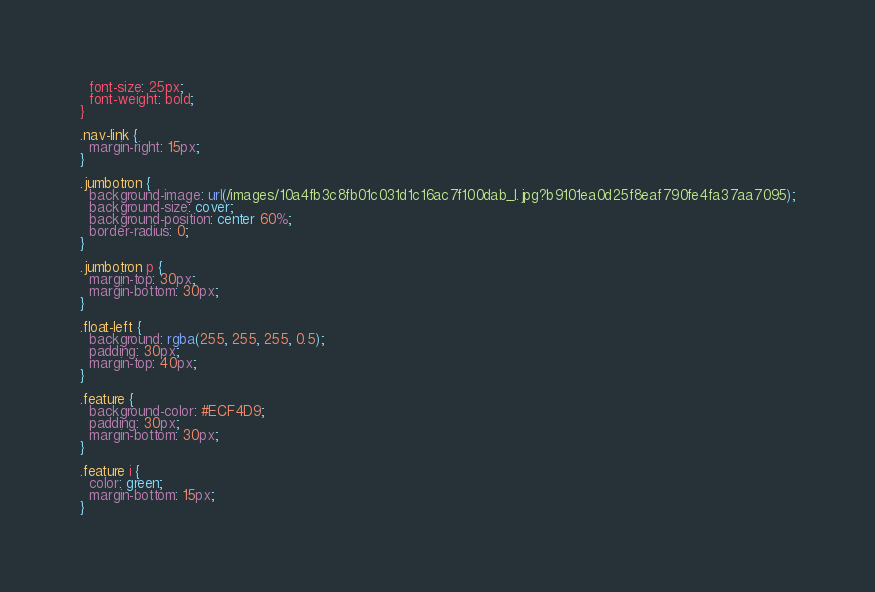Convert code to text. <code><loc_0><loc_0><loc_500><loc_500><_CSS_>  font-size: 25px;
  font-weight: bold;
}

.nav-link {
  margin-right: 15px;
}

.jumbotron {
  background-image: url(/images/10a4fb3c8fb01c031d1c16ac7f100dab_l.jpg?b9101ea0d25f8eaf790fe4fa37aa7095);
  background-size: cover;
  background-position: center 60%;
  border-radius: 0;
}

.jumbotron p {
  margin-top: 30px;
  margin-bottom: 30px;
}

.float-left {
  background: rgba(255, 255, 255, 0.5);
  padding: 30px;
  margin-top: 40px;
}

.feature {
  background-color: #ECF4D9;
  padding: 30px;
  margin-bottom: 30px;
}

.feature i {
  color: green;
  margin-bottom: 15px;
}

</code> 